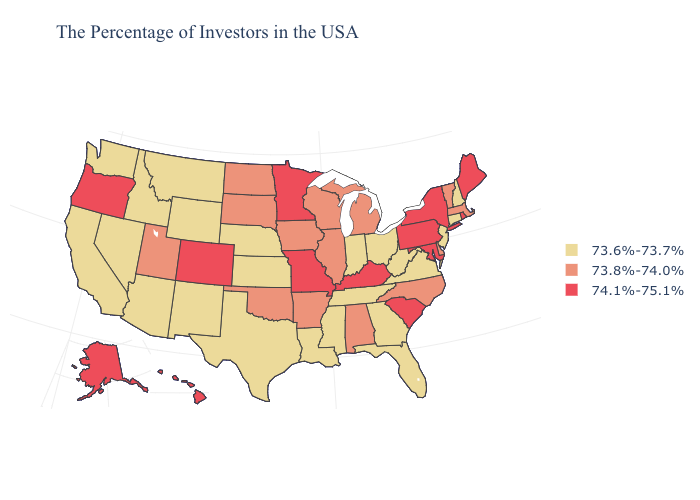What is the highest value in the West ?
Short answer required. 74.1%-75.1%. Name the states that have a value in the range 73.8%-74.0%?
Answer briefly. Massachusetts, Vermont, Delaware, North Carolina, Michigan, Alabama, Wisconsin, Illinois, Arkansas, Iowa, Oklahoma, South Dakota, North Dakota, Utah. Name the states that have a value in the range 74.1%-75.1%?
Concise answer only. Maine, Rhode Island, New York, Maryland, Pennsylvania, South Carolina, Kentucky, Missouri, Minnesota, Colorado, Oregon, Alaska, Hawaii. What is the highest value in states that border Maine?
Quick response, please. 73.6%-73.7%. Does Minnesota have the same value as Massachusetts?
Quick response, please. No. Does Wisconsin have the lowest value in the MidWest?
Quick response, please. No. Does the map have missing data?
Quick response, please. No. What is the value of Wyoming?
Short answer required. 73.6%-73.7%. Name the states that have a value in the range 73.8%-74.0%?
Answer briefly. Massachusetts, Vermont, Delaware, North Carolina, Michigan, Alabama, Wisconsin, Illinois, Arkansas, Iowa, Oklahoma, South Dakota, North Dakota, Utah. Does Nebraska have the lowest value in the USA?
Answer briefly. Yes. Does South Carolina have the lowest value in the USA?
Concise answer only. No. What is the value of Nevada?
Keep it brief. 73.6%-73.7%. Name the states that have a value in the range 73.6%-73.7%?
Write a very short answer. New Hampshire, Connecticut, New Jersey, Virginia, West Virginia, Ohio, Florida, Georgia, Indiana, Tennessee, Mississippi, Louisiana, Kansas, Nebraska, Texas, Wyoming, New Mexico, Montana, Arizona, Idaho, Nevada, California, Washington. Is the legend a continuous bar?
Concise answer only. No. What is the lowest value in the West?
Short answer required. 73.6%-73.7%. 